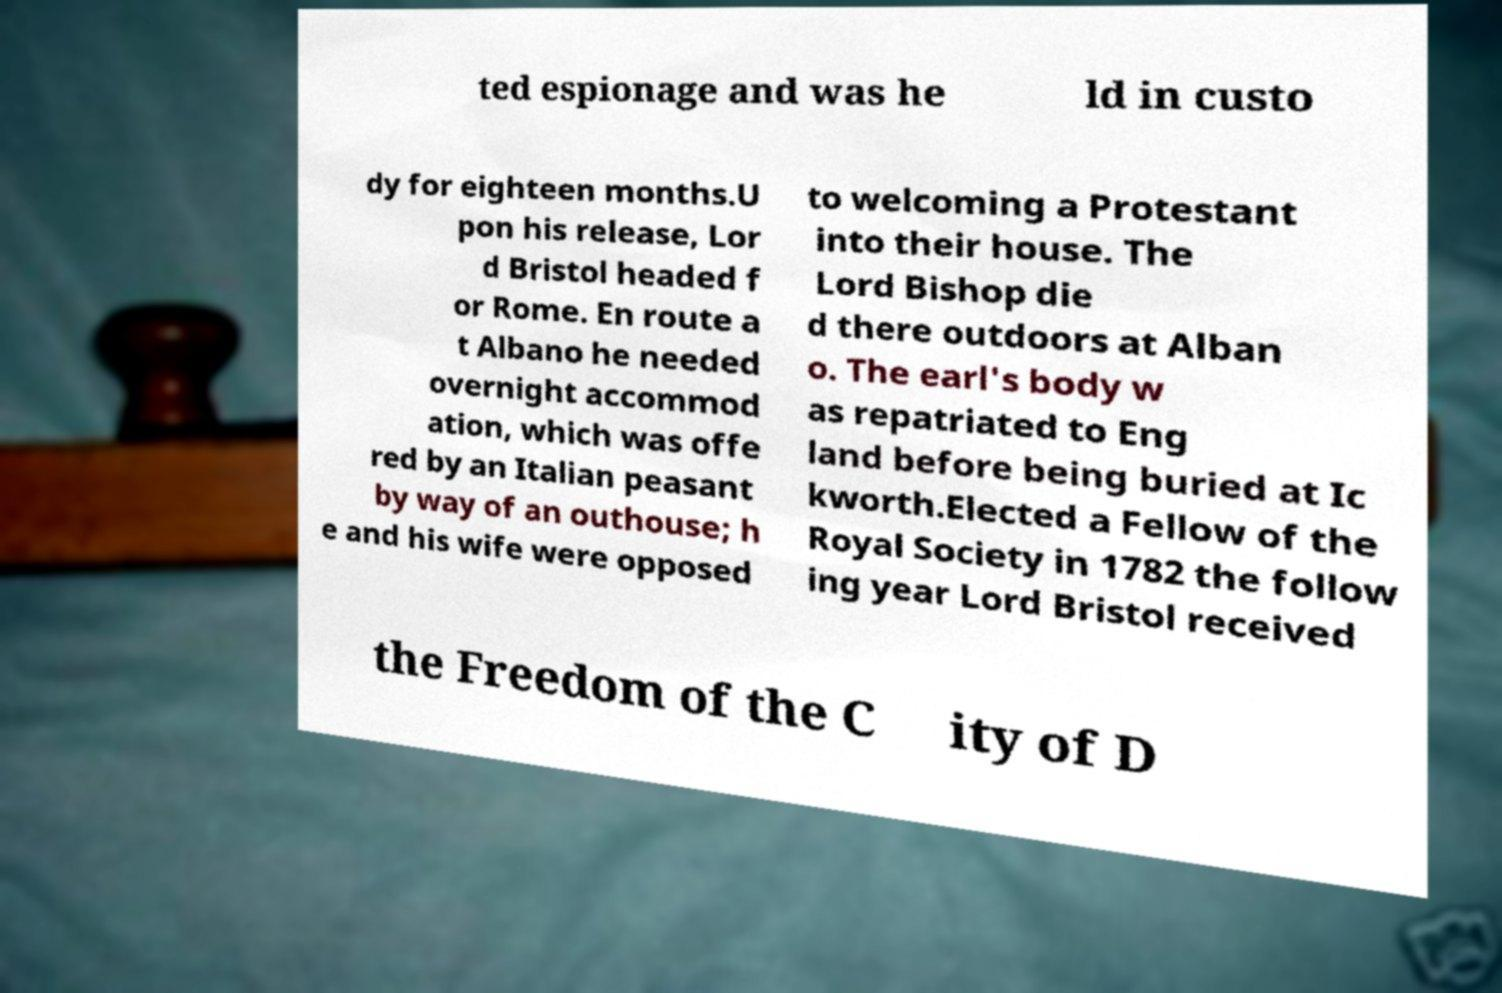I need the written content from this picture converted into text. Can you do that? ted espionage and was he ld in custo dy for eighteen months.U pon his release, Lor d Bristol headed f or Rome. En route a t Albano he needed overnight accommod ation, which was offe red by an Italian peasant by way of an outhouse; h e and his wife were opposed to welcoming a Protestant into their house. The Lord Bishop die d there outdoors at Alban o. The earl's body w as repatriated to Eng land before being buried at Ic kworth.Elected a Fellow of the Royal Society in 1782 the follow ing year Lord Bristol received the Freedom of the C ity of D 